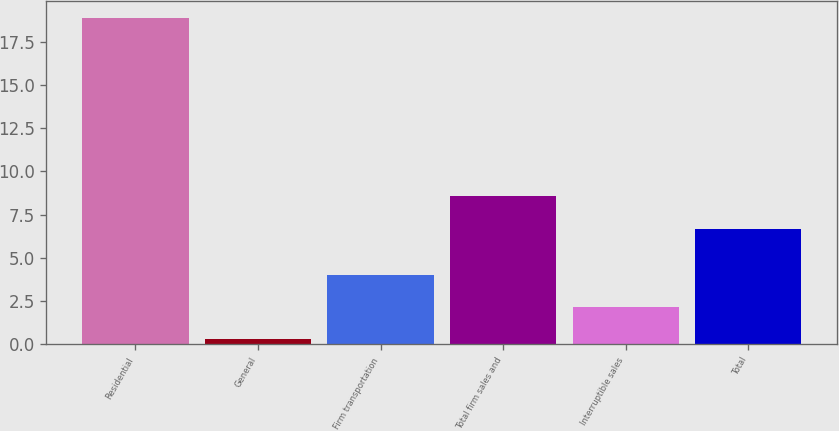<chart> <loc_0><loc_0><loc_500><loc_500><bar_chart><fcel>Residential<fcel>General<fcel>Firm transportation<fcel>Total firm sales and<fcel>Interruptible sales<fcel>Total<nl><fcel>18.9<fcel>0.3<fcel>4.02<fcel>8.56<fcel>2.16<fcel>6.7<nl></chart> 